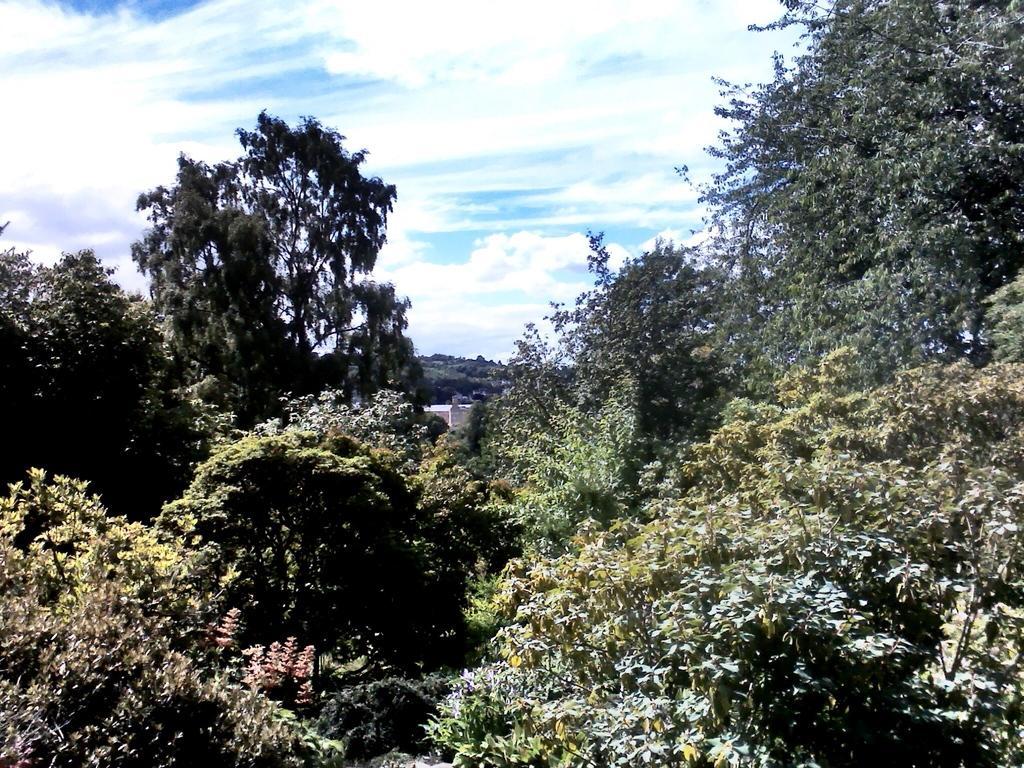Describe this image in one or two sentences. This image consists of many trees and plants. At the top, there are clouds in the sky. 